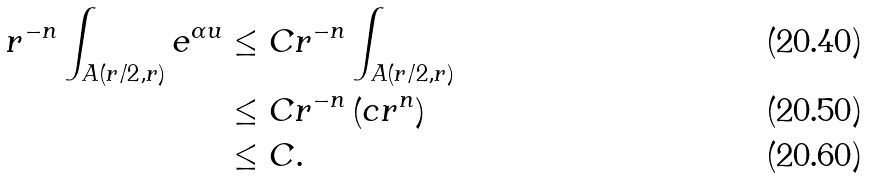Convert formula to latex. <formula><loc_0><loc_0><loc_500><loc_500>r ^ { - n } \int _ { A ( r / 2 , r ) } e ^ { \alpha u } & \leq C r ^ { - n } \int _ { A ( r / 2 , r ) } \\ & \leq C r ^ { - n } \left ( c r ^ { n } \right ) \\ & \leq C .</formula> 